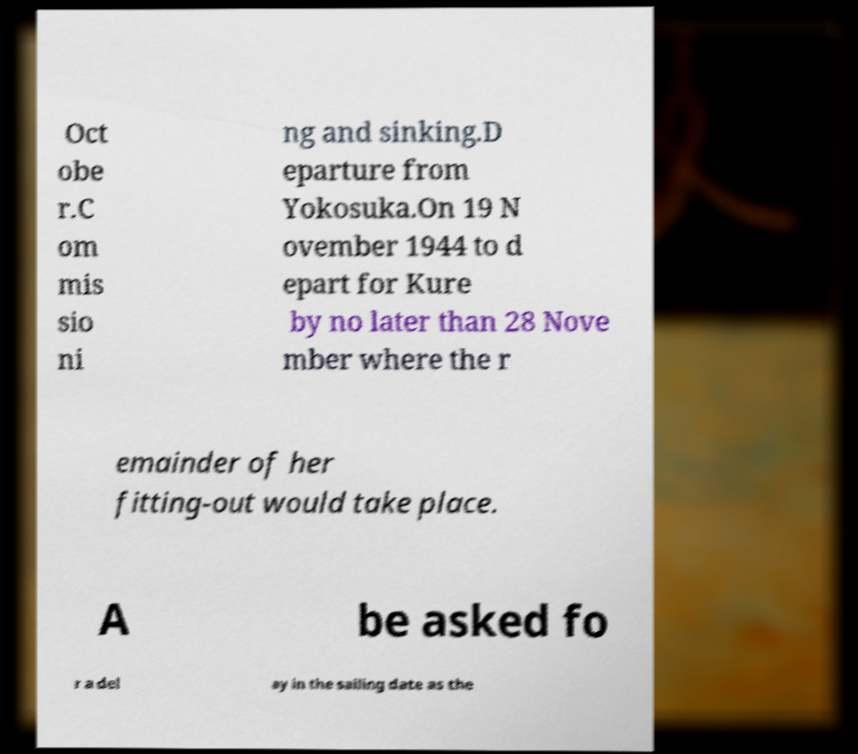Could you extract and type out the text from this image? Oct obe r.C om mis sio ni ng and sinking.D eparture from Yokosuka.On 19 N ovember 1944 to d epart for Kure by no later than 28 Nove mber where the r emainder of her fitting-out would take place. A be asked fo r a del ay in the sailing date as the 